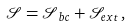<formula> <loc_0><loc_0><loc_500><loc_500>\mathcal { S = S } _ { b c } + \mathcal { S } _ { e x t } \, ,</formula> 